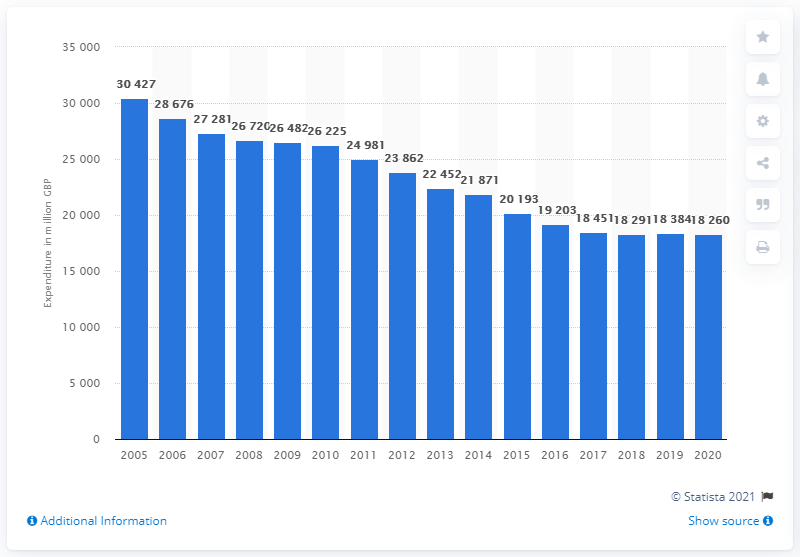List a handful of essential elements in this visual. In 2020, the total annual expenditure on tobacco in the UK was 18,260 million pounds. In 2005, households purchased a significant amount of tobacco, with the exact amount being 30,427 units. 